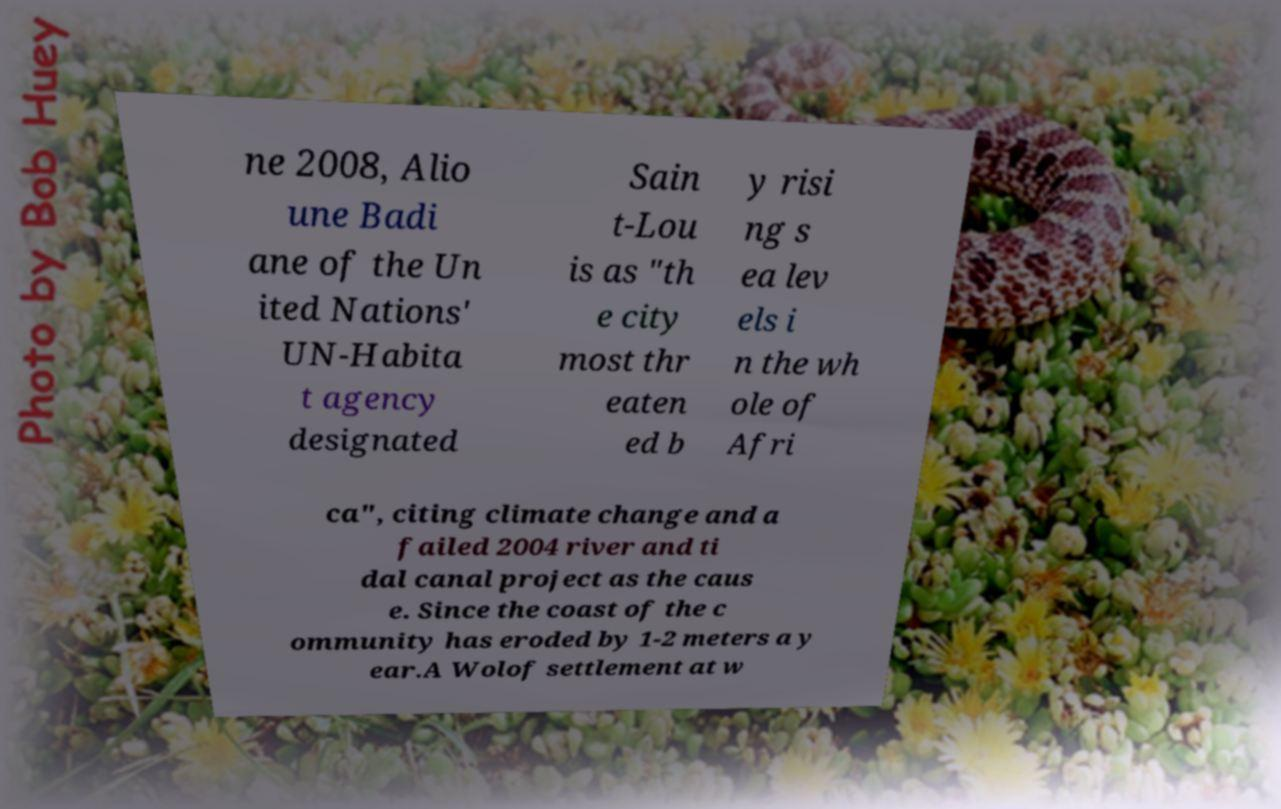For documentation purposes, I need the text within this image transcribed. Could you provide that? ne 2008, Alio une Badi ane of the Un ited Nations' UN-Habita t agency designated Sain t-Lou is as "th e city most thr eaten ed b y risi ng s ea lev els i n the wh ole of Afri ca", citing climate change and a failed 2004 river and ti dal canal project as the caus e. Since the coast of the c ommunity has eroded by 1-2 meters a y ear.A Wolof settlement at w 